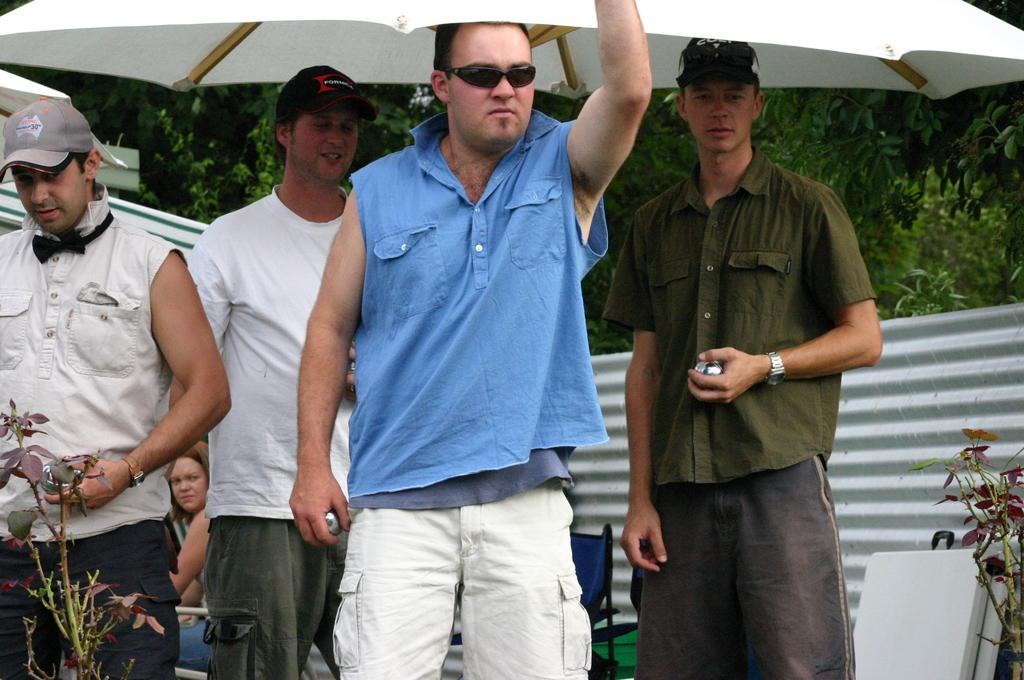How many men are present in the image? There are four men in the image. Can you describe any specific features of one of the men? One of the men is wearing spectacles. What object can be seen at the top of the image? There is a white color umbrella in the image. What is visible in the background of the image? There are trees in the background of the image. What time of day is it in the image, given that it is morning? The provided facts do not mention the time of day, so we cannot determine if it is morning or not. Can you tell me how many cattle are present in the image? There are no cattle present in the image. 